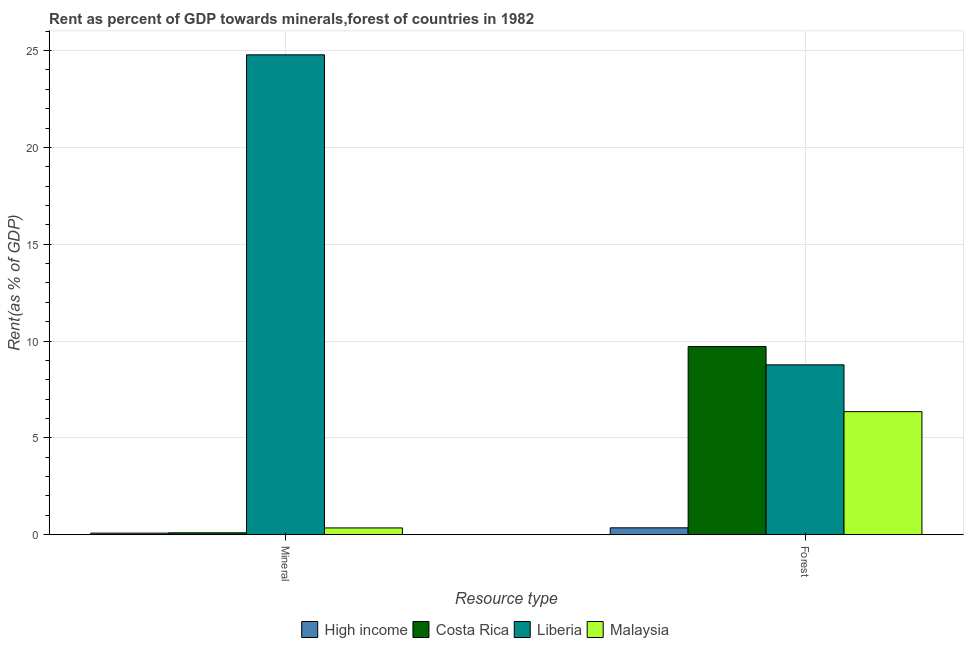How many different coloured bars are there?
Your answer should be compact. 4. How many groups of bars are there?
Offer a terse response. 2. Are the number of bars per tick equal to the number of legend labels?
Ensure brevity in your answer.  Yes. How many bars are there on the 2nd tick from the right?
Make the answer very short. 4. What is the label of the 1st group of bars from the left?
Your answer should be compact. Mineral. What is the forest rent in High income?
Your answer should be compact. 0.36. Across all countries, what is the maximum mineral rent?
Ensure brevity in your answer.  24.78. Across all countries, what is the minimum forest rent?
Offer a terse response. 0.36. In which country was the mineral rent minimum?
Offer a terse response. High income. What is the total mineral rent in the graph?
Your answer should be very brief. 25.31. What is the difference between the mineral rent in Costa Rica and that in High income?
Offer a terse response. 0.02. What is the difference between the forest rent in Liberia and the mineral rent in Malaysia?
Give a very brief answer. 8.42. What is the average mineral rent per country?
Your answer should be compact. 6.33. What is the difference between the forest rent and mineral rent in Liberia?
Make the answer very short. -16.01. In how many countries, is the mineral rent greater than 11 %?
Make the answer very short. 1. What is the ratio of the mineral rent in High income to that in Liberia?
Make the answer very short. 0. In how many countries, is the mineral rent greater than the average mineral rent taken over all countries?
Provide a succinct answer. 1. What does the 2nd bar from the left in Forest represents?
Offer a very short reply. Costa Rica. Are all the bars in the graph horizontal?
Keep it short and to the point. No. Are the values on the major ticks of Y-axis written in scientific E-notation?
Give a very brief answer. No. Does the graph contain any zero values?
Your answer should be compact. No. How are the legend labels stacked?
Provide a succinct answer. Horizontal. What is the title of the graph?
Your response must be concise. Rent as percent of GDP towards minerals,forest of countries in 1982. What is the label or title of the X-axis?
Offer a terse response. Resource type. What is the label or title of the Y-axis?
Your answer should be very brief. Rent(as % of GDP). What is the Rent(as % of GDP) of High income in Mineral?
Provide a succinct answer. 0.08. What is the Rent(as % of GDP) of Costa Rica in Mineral?
Offer a very short reply. 0.1. What is the Rent(as % of GDP) in Liberia in Mineral?
Provide a succinct answer. 24.78. What is the Rent(as % of GDP) in Malaysia in Mineral?
Your response must be concise. 0.35. What is the Rent(as % of GDP) of High income in Forest?
Offer a very short reply. 0.36. What is the Rent(as % of GDP) in Costa Rica in Forest?
Keep it short and to the point. 9.71. What is the Rent(as % of GDP) of Liberia in Forest?
Your answer should be compact. 8.77. What is the Rent(as % of GDP) of Malaysia in Forest?
Offer a terse response. 6.35. Across all Resource type, what is the maximum Rent(as % of GDP) in High income?
Your answer should be compact. 0.36. Across all Resource type, what is the maximum Rent(as % of GDP) in Costa Rica?
Provide a short and direct response. 9.71. Across all Resource type, what is the maximum Rent(as % of GDP) in Liberia?
Your answer should be very brief. 24.78. Across all Resource type, what is the maximum Rent(as % of GDP) of Malaysia?
Offer a very short reply. 6.35. Across all Resource type, what is the minimum Rent(as % of GDP) of High income?
Make the answer very short. 0.08. Across all Resource type, what is the minimum Rent(as % of GDP) of Costa Rica?
Make the answer very short. 0.1. Across all Resource type, what is the minimum Rent(as % of GDP) of Liberia?
Your response must be concise. 8.77. Across all Resource type, what is the minimum Rent(as % of GDP) in Malaysia?
Ensure brevity in your answer.  0.35. What is the total Rent(as % of GDP) in High income in the graph?
Offer a terse response. 0.44. What is the total Rent(as % of GDP) in Costa Rica in the graph?
Keep it short and to the point. 9.81. What is the total Rent(as % of GDP) of Liberia in the graph?
Provide a succinct answer. 33.55. What is the total Rent(as % of GDP) in Malaysia in the graph?
Offer a very short reply. 6.7. What is the difference between the Rent(as % of GDP) in High income in Mineral and that in Forest?
Give a very brief answer. -0.28. What is the difference between the Rent(as % of GDP) of Costa Rica in Mineral and that in Forest?
Ensure brevity in your answer.  -9.62. What is the difference between the Rent(as % of GDP) in Liberia in Mineral and that in Forest?
Offer a terse response. 16.01. What is the difference between the Rent(as % of GDP) in Malaysia in Mineral and that in Forest?
Offer a very short reply. -6. What is the difference between the Rent(as % of GDP) of High income in Mineral and the Rent(as % of GDP) of Costa Rica in Forest?
Your answer should be compact. -9.63. What is the difference between the Rent(as % of GDP) in High income in Mineral and the Rent(as % of GDP) in Liberia in Forest?
Make the answer very short. -8.69. What is the difference between the Rent(as % of GDP) of High income in Mineral and the Rent(as % of GDP) of Malaysia in Forest?
Make the answer very short. -6.27. What is the difference between the Rent(as % of GDP) of Costa Rica in Mineral and the Rent(as % of GDP) of Liberia in Forest?
Keep it short and to the point. -8.67. What is the difference between the Rent(as % of GDP) of Costa Rica in Mineral and the Rent(as % of GDP) of Malaysia in Forest?
Provide a short and direct response. -6.26. What is the difference between the Rent(as % of GDP) of Liberia in Mineral and the Rent(as % of GDP) of Malaysia in Forest?
Ensure brevity in your answer.  18.43. What is the average Rent(as % of GDP) of High income per Resource type?
Your response must be concise. 0.22. What is the average Rent(as % of GDP) of Costa Rica per Resource type?
Keep it short and to the point. 4.91. What is the average Rent(as % of GDP) of Liberia per Resource type?
Offer a very short reply. 16.77. What is the average Rent(as % of GDP) in Malaysia per Resource type?
Your response must be concise. 3.35. What is the difference between the Rent(as % of GDP) of High income and Rent(as % of GDP) of Costa Rica in Mineral?
Keep it short and to the point. -0.02. What is the difference between the Rent(as % of GDP) of High income and Rent(as % of GDP) of Liberia in Mineral?
Give a very brief answer. -24.7. What is the difference between the Rent(as % of GDP) of High income and Rent(as % of GDP) of Malaysia in Mineral?
Your answer should be very brief. -0.27. What is the difference between the Rent(as % of GDP) of Costa Rica and Rent(as % of GDP) of Liberia in Mineral?
Offer a terse response. -24.68. What is the difference between the Rent(as % of GDP) of Costa Rica and Rent(as % of GDP) of Malaysia in Mineral?
Provide a short and direct response. -0.25. What is the difference between the Rent(as % of GDP) in Liberia and Rent(as % of GDP) in Malaysia in Mineral?
Your response must be concise. 24.43. What is the difference between the Rent(as % of GDP) of High income and Rent(as % of GDP) of Costa Rica in Forest?
Provide a short and direct response. -9.36. What is the difference between the Rent(as % of GDP) of High income and Rent(as % of GDP) of Liberia in Forest?
Provide a short and direct response. -8.41. What is the difference between the Rent(as % of GDP) of High income and Rent(as % of GDP) of Malaysia in Forest?
Ensure brevity in your answer.  -6. What is the difference between the Rent(as % of GDP) in Costa Rica and Rent(as % of GDP) in Liberia in Forest?
Provide a short and direct response. 0.95. What is the difference between the Rent(as % of GDP) in Costa Rica and Rent(as % of GDP) in Malaysia in Forest?
Your response must be concise. 3.36. What is the difference between the Rent(as % of GDP) of Liberia and Rent(as % of GDP) of Malaysia in Forest?
Your answer should be compact. 2.42. What is the ratio of the Rent(as % of GDP) in High income in Mineral to that in Forest?
Offer a terse response. 0.23. What is the ratio of the Rent(as % of GDP) of Liberia in Mineral to that in Forest?
Give a very brief answer. 2.83. What is the ratio of the Rent(as % of GDP) in Malaysia in Mineral to that in Forest?
Provide a succinct answer. 0.06. What is the difference between the highest and the second highest Rent(as % of GDP) of High income?
Provide a short and direct response. 0.28. What is the difference between the highest and the second highest Rent(as % of GDP) in Costa Rica?
Offer a very short reply. 9.62. What is the difference between the highest and the second highest Rent(as % of GDP) in Liberia?
Provide a short and direct response. 16.01. What is the difference between the highest and the second highest Rent(as % of GDP) in Malaysia?
Keep it short and to the point. 6. What is the difference between the highest and the lowest Rent(as % of GDP) in High income?
Your answer should be very brief. 0.28. What is the difference between the highest and the lowest Rent(as % of GDP) in Costa Rica?
Keep it short and to the point. 9.62. What is the difference between the highest and the lowest Rent(as % of GDP) of Liberia?
Provide a short and direct response. 16.01. What is the difference between the highest and the lowest Rent(as % of GDP) in Malaysia?
Provide a succinct answer. 6. 